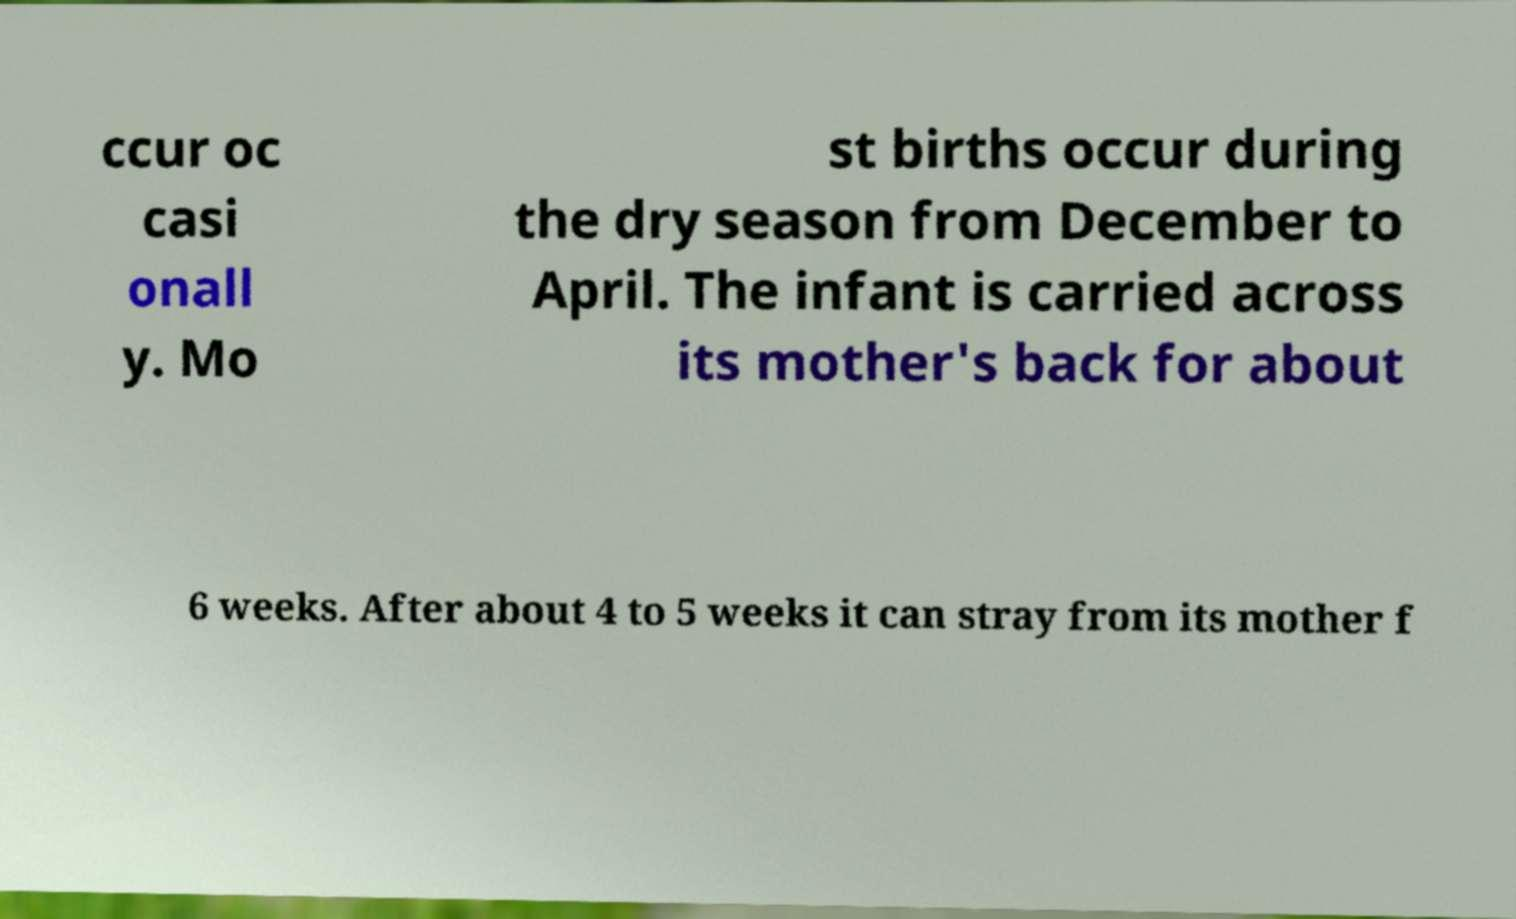Please read and relay the text visible in this image. What does it say? ccur oc casi onall y. Mo st births occur during the dry season from December to April. The infant is carried across its mother's back for about 6 weeks. After about 4 to 5 weeks it can stray from its mother f 